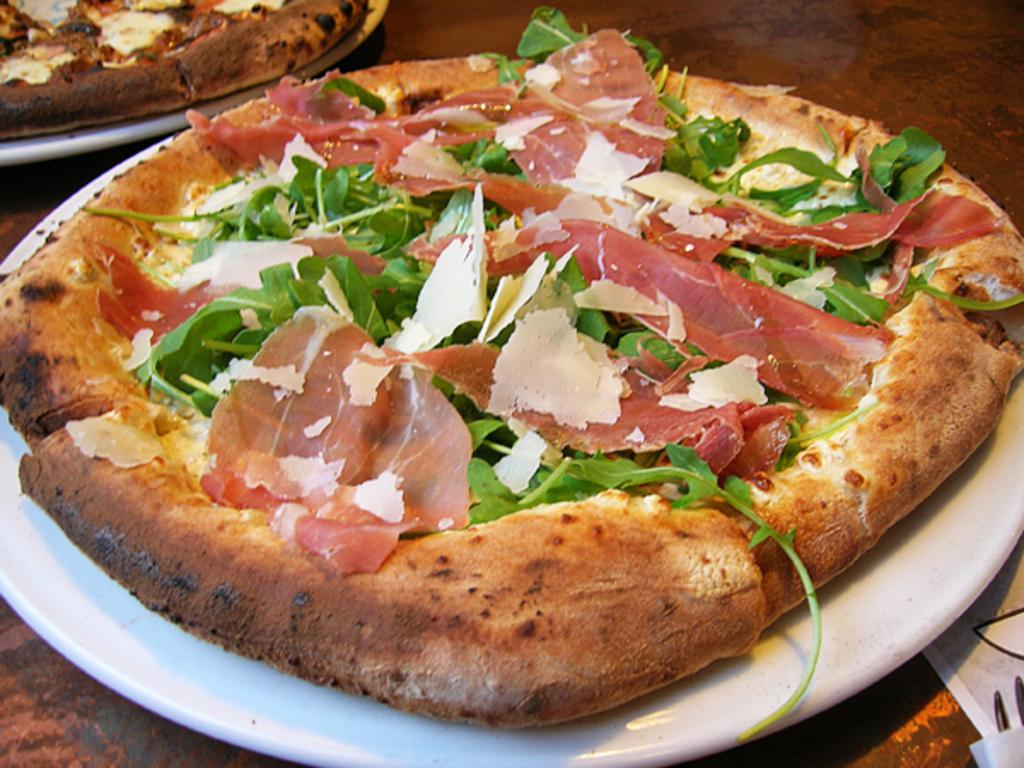How many plates are visible in the image? There are two plates in the image. What are the plates placed on? The plates are on an object. What can be found inside the plates? There are food items in the plates. How does the plate on the left turn into a quarter in the image? The plate on the left does not turn into a quarter in the image; it remains a plate with food items. 